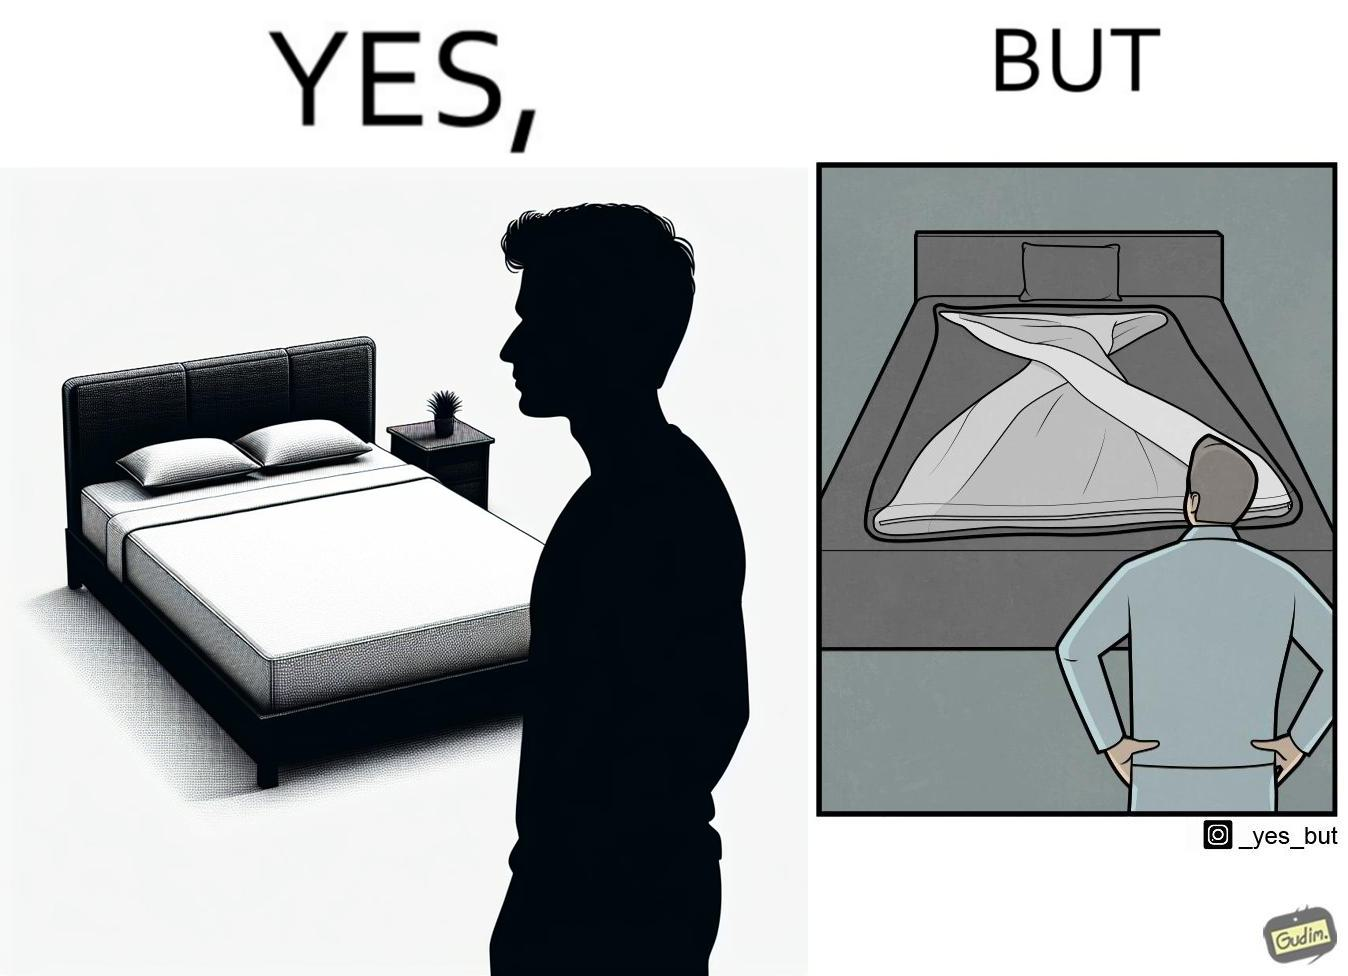Describe what you see in the left and right parts of this image. In the left part of the image: The image shows a man looking at his bed. His bed seems well made with blanket and pillow properly arranged on the mattress. In the right part of the image: The image shows a man looking at his bed. The image also shows the actual blanket inside its cover on the bed. The blanked is all twisted inside the cover and is not properly set. 